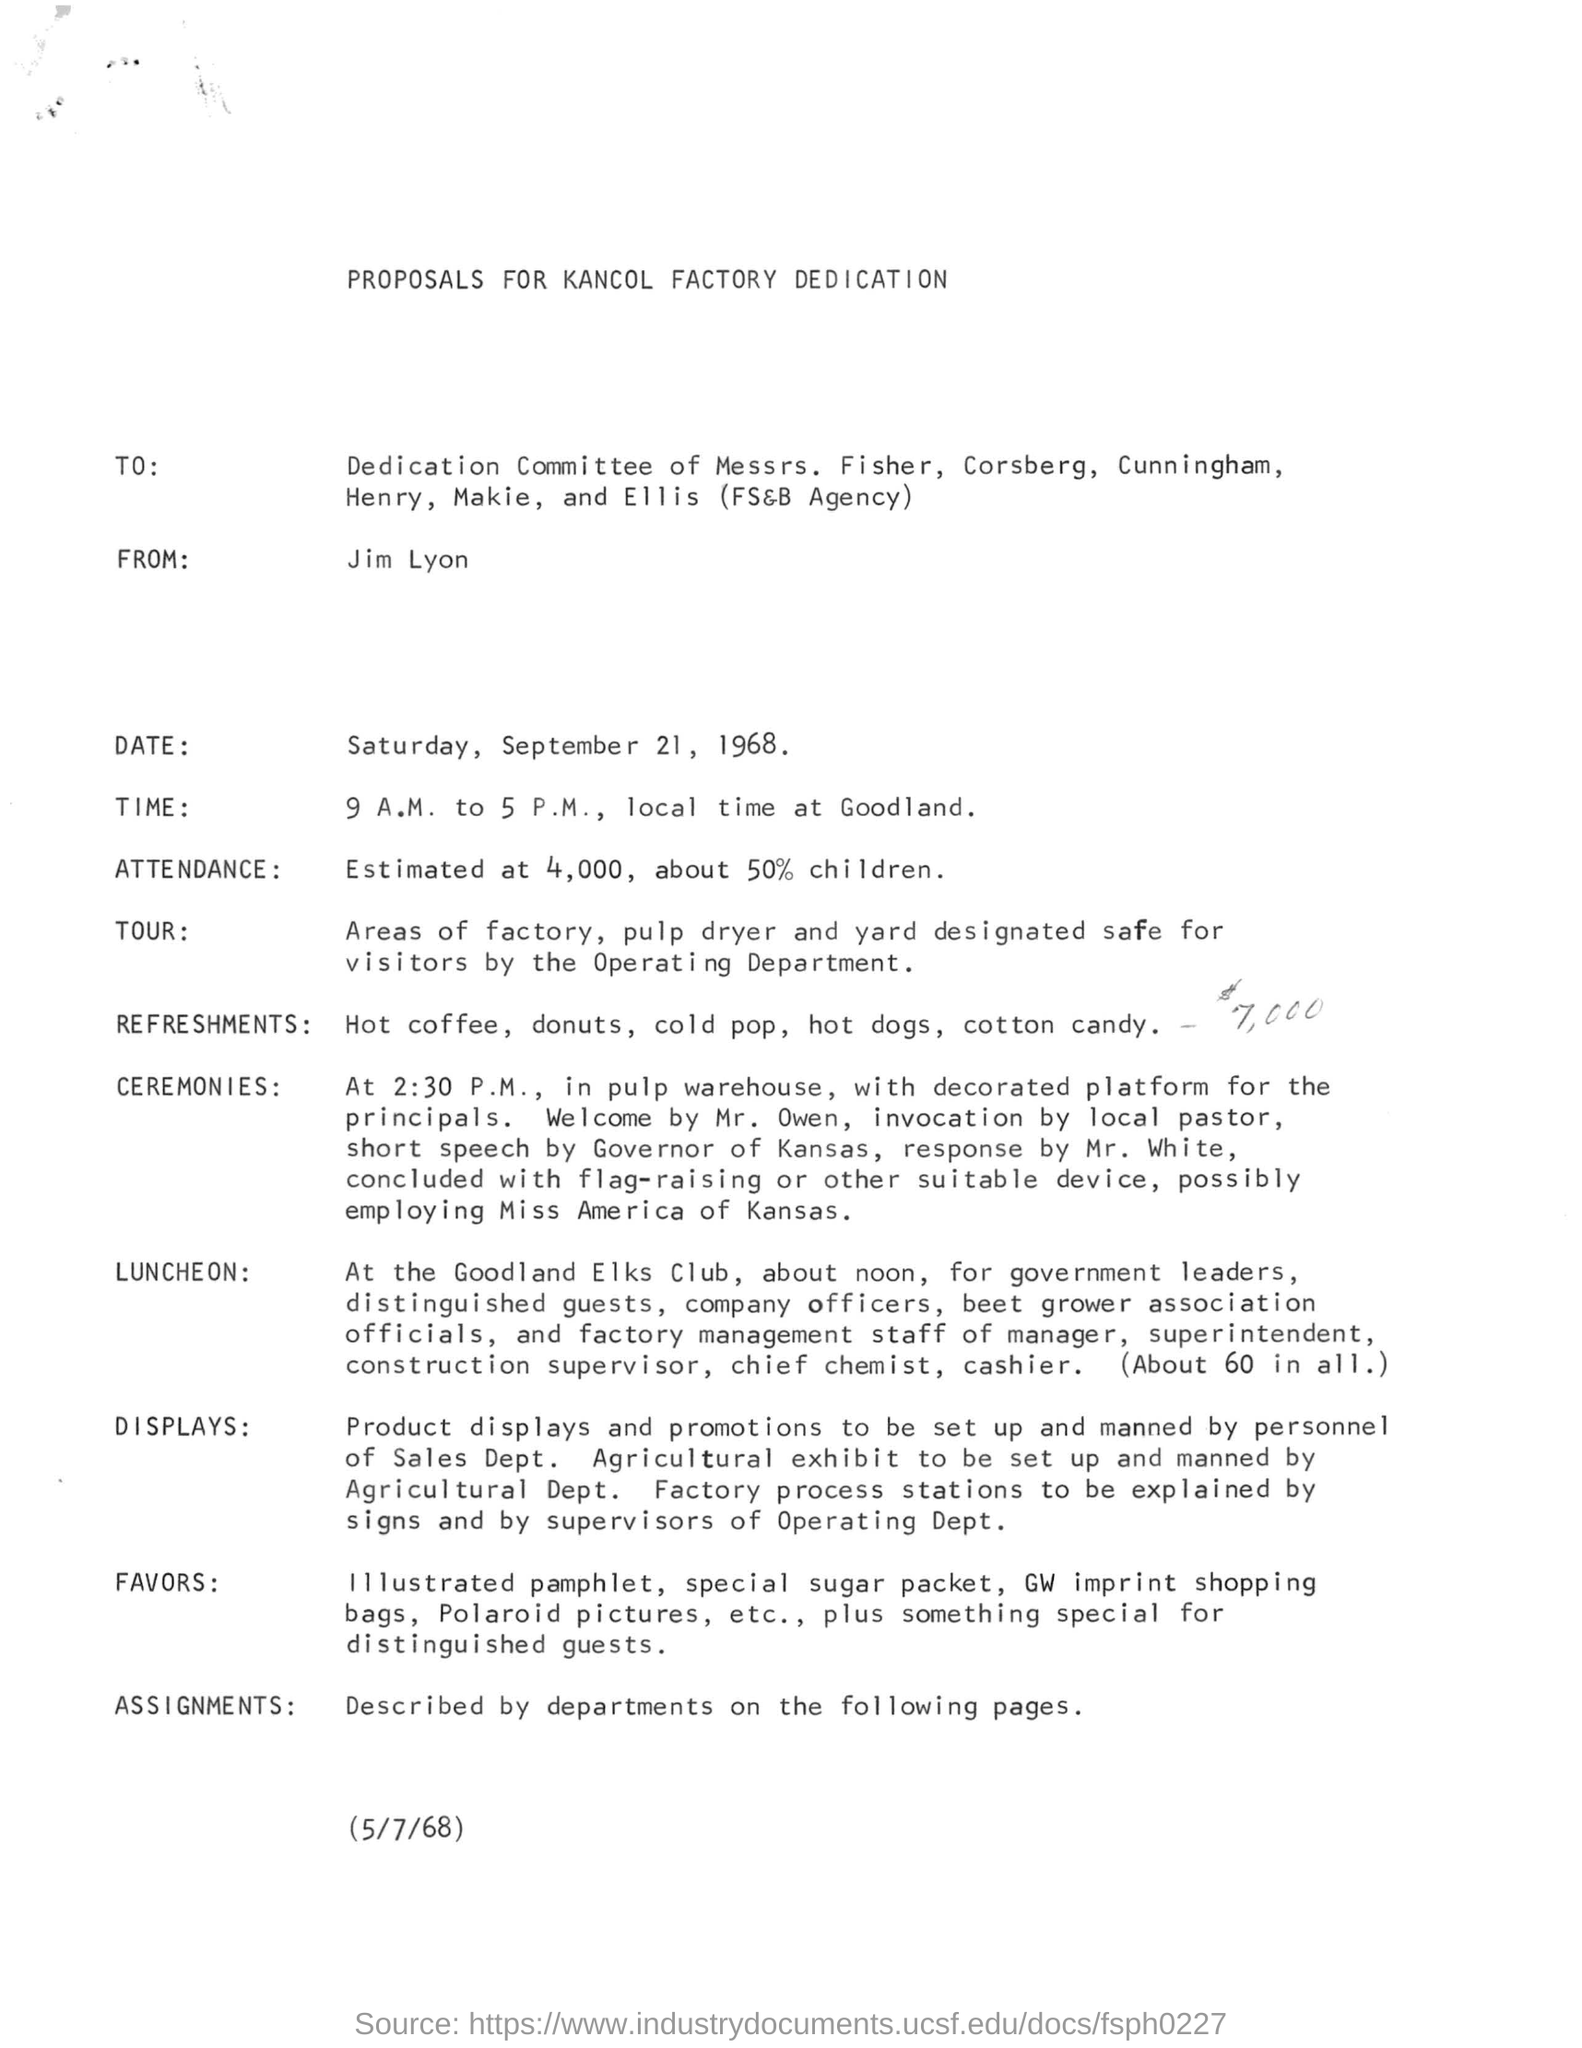Specify some key components in this picture. Jim Lyon is mentioned in the FROM field. The date of the ceremony is Saturday, September 21, 1968. The LUNCHEON is scheduled at the GOODLAND ELKS CLUB. The sender of this proposal is Jim Lyon. 